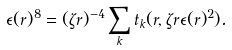<formula> <loc_0><loc_0><loc_500><loc_500>\epsilon ( r ) ^ { 8 } = ( \zeta r ) ^ { - 4 } \sum _ { k } t _ { k } ( r , \zeta r \epsilon ( r ) ^ { 2 } ) .</formula> 